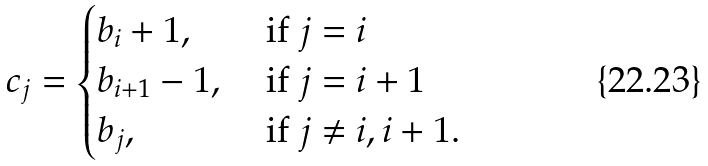<formula> <loc_0><loc_0><loc_500><loc_500>c _ { j } = \begin{cases} b _ { i } + 1 , & \text { if } j = i \\ b _ { i + 1 } - 1 , & \text { if } j = i + 1 \\ b _ { j } , & \text { if } j \neq i , i + 1 . \end{cases}</formula> 